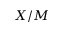Convert formula to latex. <formula><loc_0><loc_0><loc_500><loc_500>X / M</formula> 